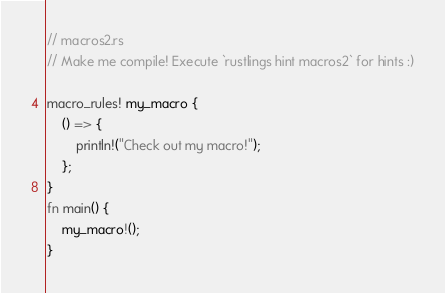<code> <loc_0><loc_0><loc_500><loc_500><_Rust_>// macros2.rs
// Make me compile! Execute `rustlings hint macros2` for hints :)

macro_rules! my_macro {
    () => {
        println!("Check out my macro!");
    };
}
fn main() {
    my_macro!();
}


</code> 